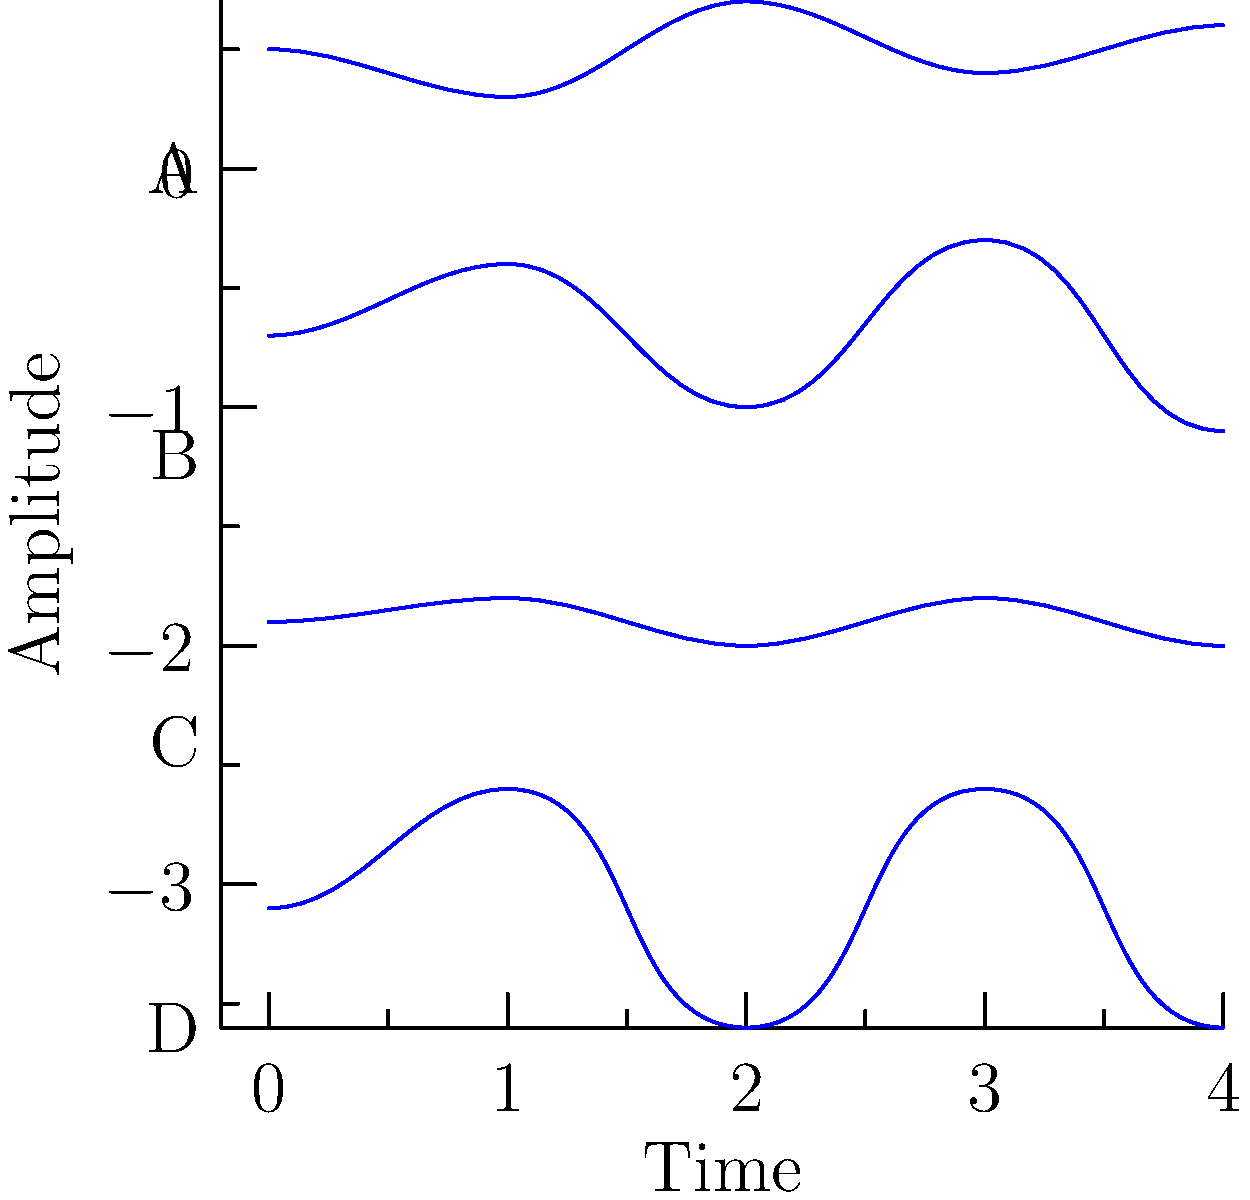As a CentralSauce staff member preparing for a guest interview with a sound engineer, you come across these waveform patterns. Which of these waveforms (A, B, C, or D) most likely represents a piano note? To identify the waveform that most likely represents a piano note, let's analyze each pattern:

1. Waveform A: Shows a relatively smooth, periodic pattern with some variation in amplitude. This could represent a sustained instrument, but lacks the sharp attack characteristic of a piano.

2. Waveform B: Displays a sharp initial peak followed by a rapid decay and then some sustained oscillation. This pattern is highly characteristic of a piano note:
   - The sharp initial peak represents the hammer striking the string.
   - The rapid decay represents the initial bright tone quickly fading.
   - The sustained oscillation represents the string continuing to vibrate.

3. Waveform C: Shows a very regular, consistent pattern with little variation in amplitude. This is more characteristic of a synthesized tone or a wind instrument playing a steady note.

4. Waveform D: Displays a perfect sawtooth wave, which is typically associated with synthesizers or electronic instruments, not acoustic instruments like a piano.

Given these characteristics, waveform B most closely matches the expected waveform of a piano note, with its distinctive attack-decay-sustain pattern.
Answer: B 